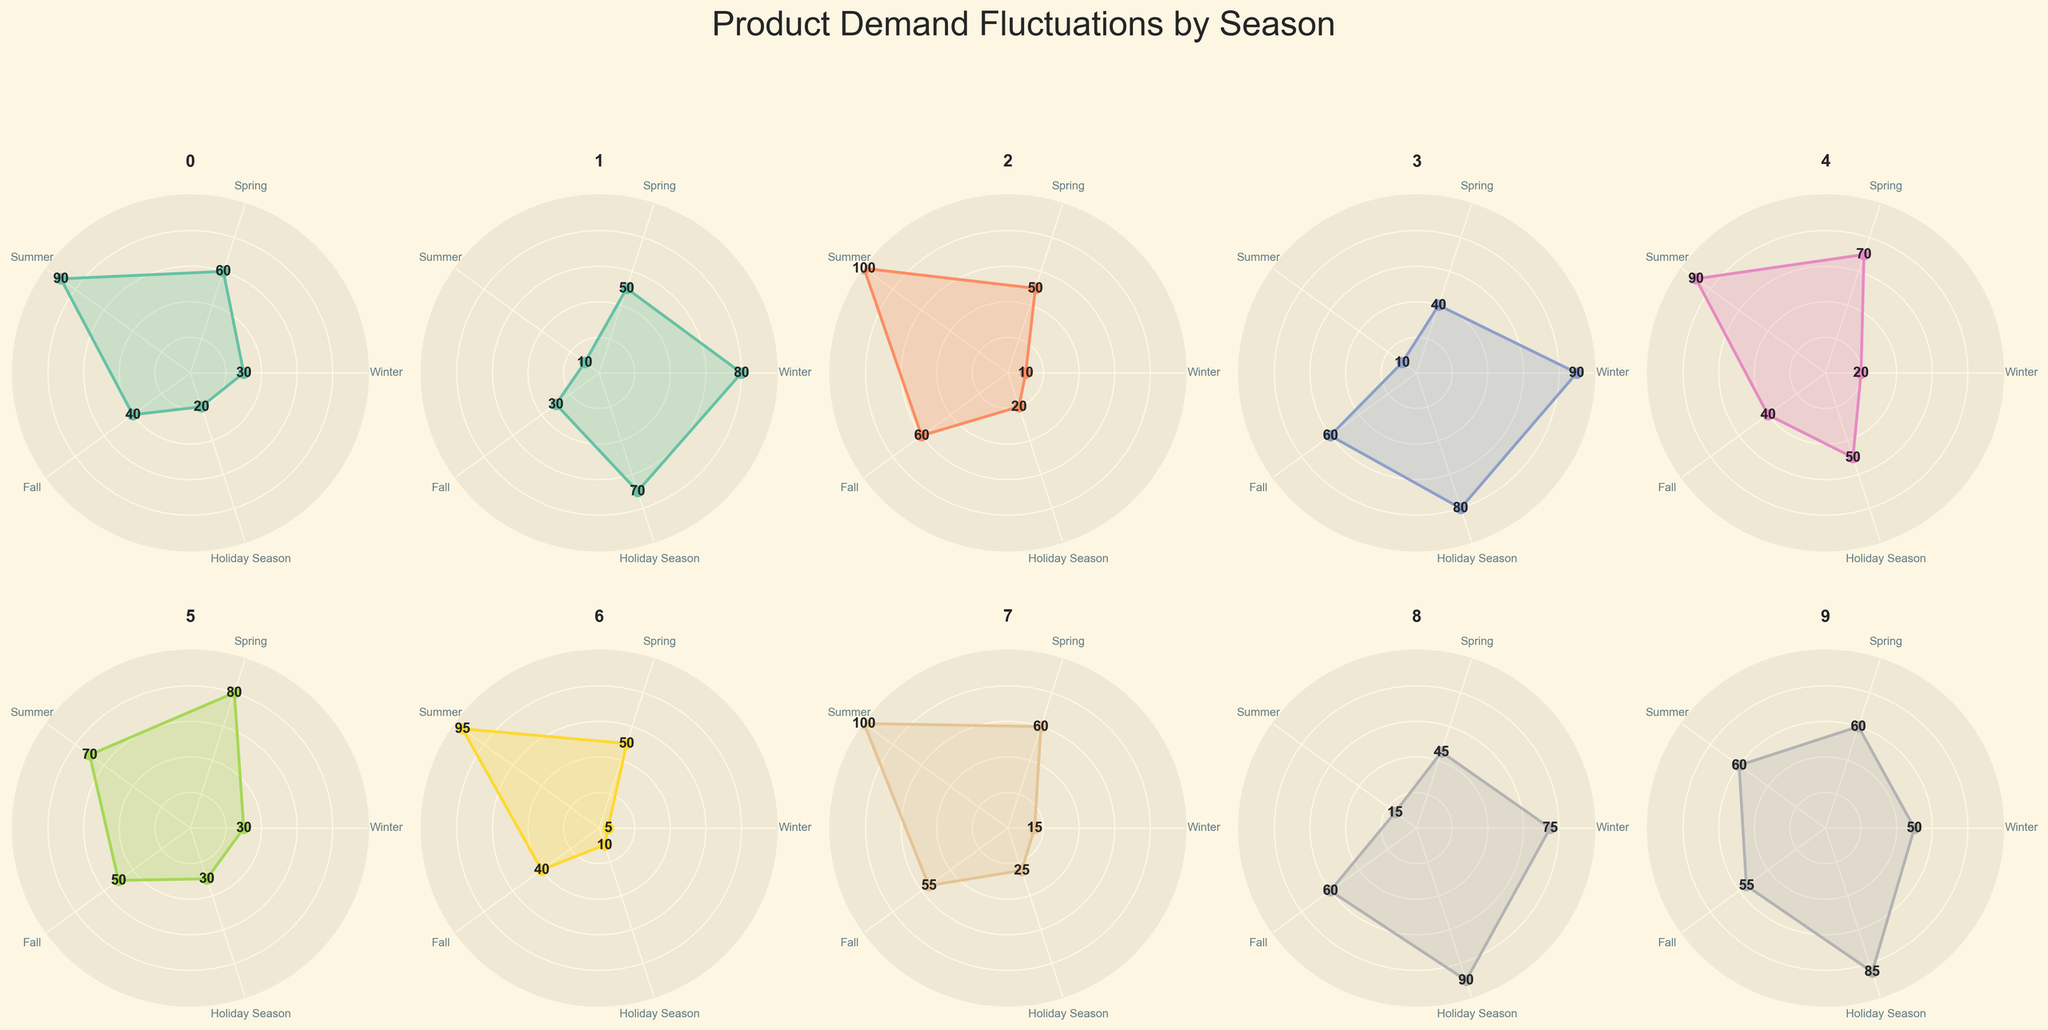What is the product with the highest demand in Winter? To find the product with the highest demand in Winter, look at the first value of each radar chart subplot. Coats and Jackets have the highest value of 90 in Winter.
Answer: Coats and Jackets Which product shows the most consistent demand across all seasons? Identify the product whose radar chart forms the most balanced shape, with less fluctuation in values. Electronics has a relatively consistent demand ranging from 50 to 85 across all seasons.
Answer: Electronics What is the average demand for Ice Cream in all seasons? Add the seasonal values for Ice Cream: 30 + 60 + 90 + 40 + 20, which sums to 240. Then divide by the number of seasons (5). The average demand is 240 / 5.
Answer: 48 Which product has the lowest demand during the Holiday Season? Look at the last value in each product's radar chart. Swimwear has the lowest demand during the Holiday Season with a value of 10.
Answer: Swimwear Is sunscreen in higher demand in Summer or Fall? Compare the values for Sunscreen in Summer and Fall. In Summer, it has a demand of 100, while in Fall, it’s 60.
Answer: Summer How does the demand for Hot Chocolate in Winter compare to that in Summer? Compare the Winter value (80) with the Summer value (10) for Hot Chocolate. The demand is much higher in Winter.
Answer: Winter What’s the sum of demands for Boots in Winter and Summer? Add the Winter value (75) and the Summer value (15) for Boots, which is 75 + 15.
Answer: 90 Which season has the smallest demand fluctuation for Grilling Equipment? Look for the season where the value of Grilling Equipment deviates the least from its other seasonal values. Demand ranges are closest in Winter, Fall, and Holiday Season. Calculate standard deviations if needed, but visually Holiday Season seems to align well.
Answer: Holiday Season Compare the demand for Gardening Tools in Spring and Swimming in Fall. Which has higher demand? Compare Spring value for Gardening Tools (80) with Fall value for Swimwear (40).
Answer: Gardening Tools in Spring What is the difference in demand for Coats and Jackets between Winter and Spring? Subtract the Spring value (40) from the Winter value (90) for Coats and Jackets. The difference is 90 - 40.
Answer: 50 